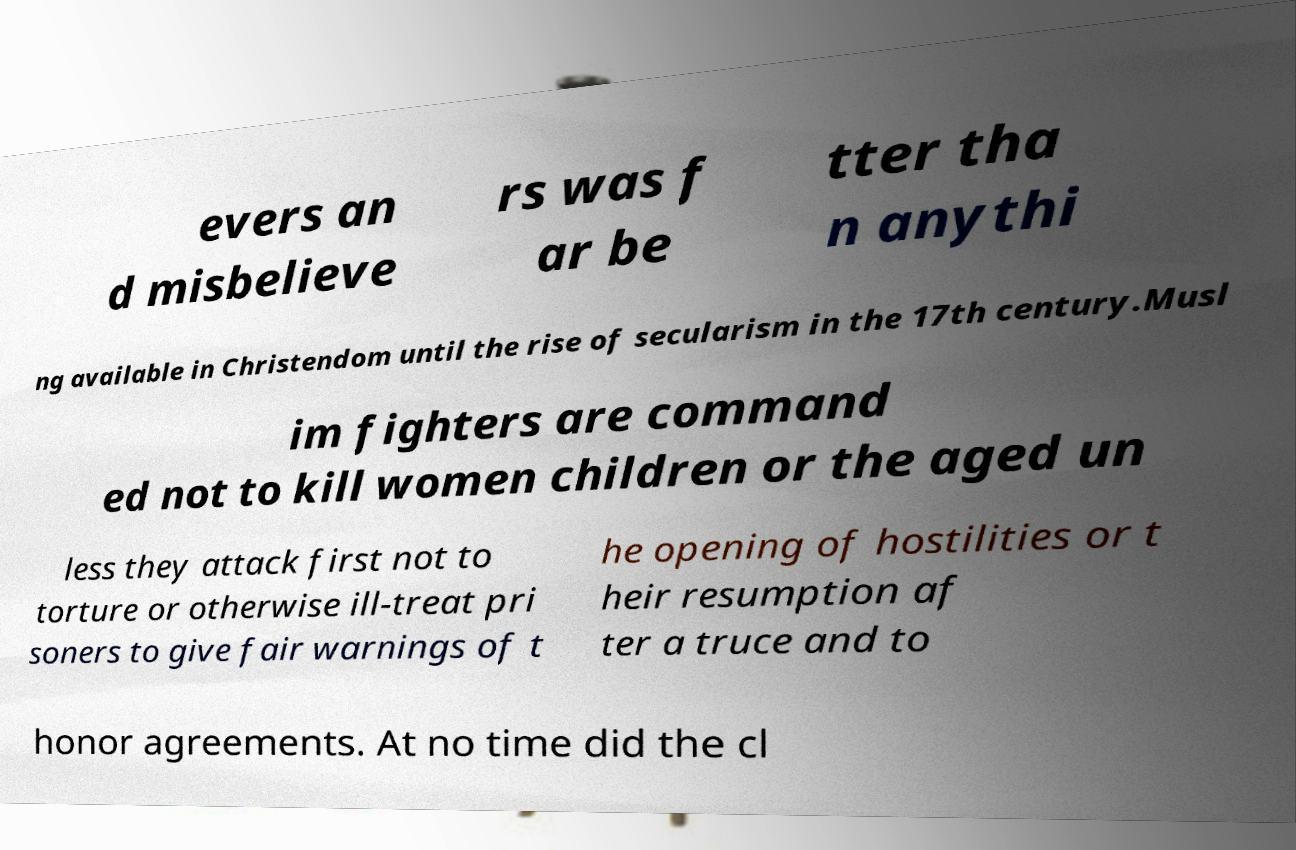Could you assist in decoding the text presented in this image and type it out clearly? evers an d misbelieve rs was f ar be tter tha n anythi ng available in Christendom until the rise of secularism in the 17th century.Musl im fighters are command ed not to kill women children or the aged un less they attack first not to torture or otherwise ill-treat pri soners to give fair warnings of t he opening of hostilities or t heir resumption af ter a truce and to honor agreements. At no time did the cl 